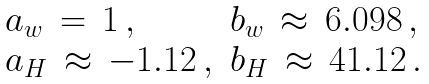Convert formula to latex. <formula><loc_0><loc_0><loc_500><loc_500>\begin{array} { l l } a _ { w } \, = \, 1 \, , & b _ { w } \, \approx \, 6 . 0 9 8 \, , \\ a _ { H } \, \approx \, - 1 . 1 2 \, , & b _ { H } \, \approx \, 4 1 . 1 2 \, . \end{array}</formula> 